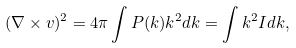Convert formula to latex. <formula><loc_0><loc_0><loc_500><loc_500>( \nabla \times { v } ) ^ { 2 } = 4 \pi \int P ( k ) k ^ { 2 } d k = \int k ^ { 2 } I d k ,</formula> 